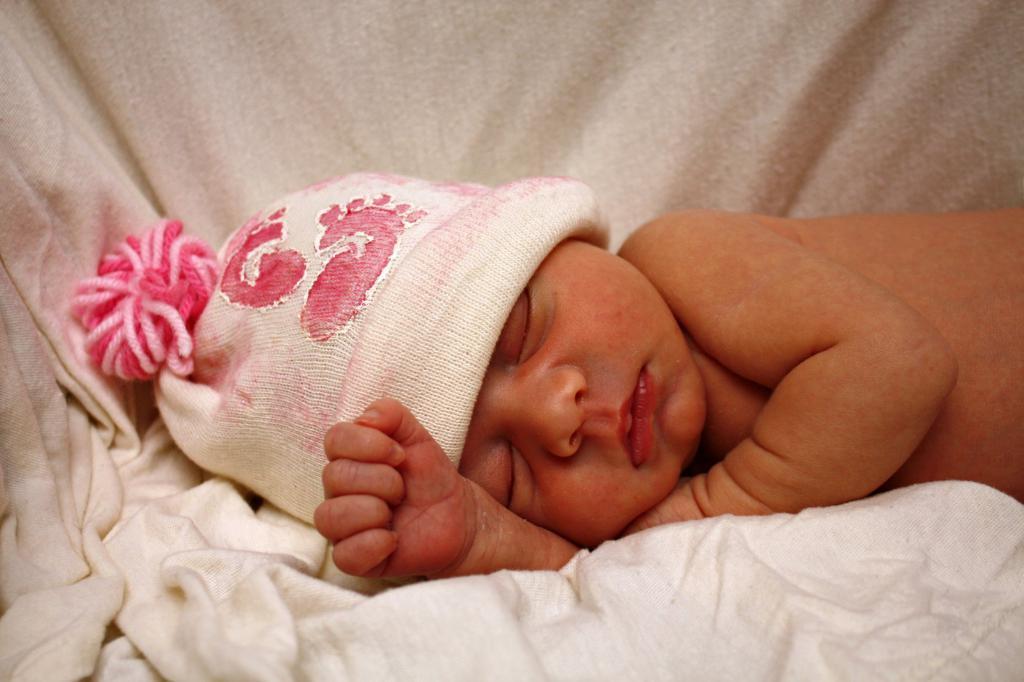Describe this image in one or two sentences. In this image, we can see a small baby sleeping, there is a blanket, there is a hat on the head of a baby. 